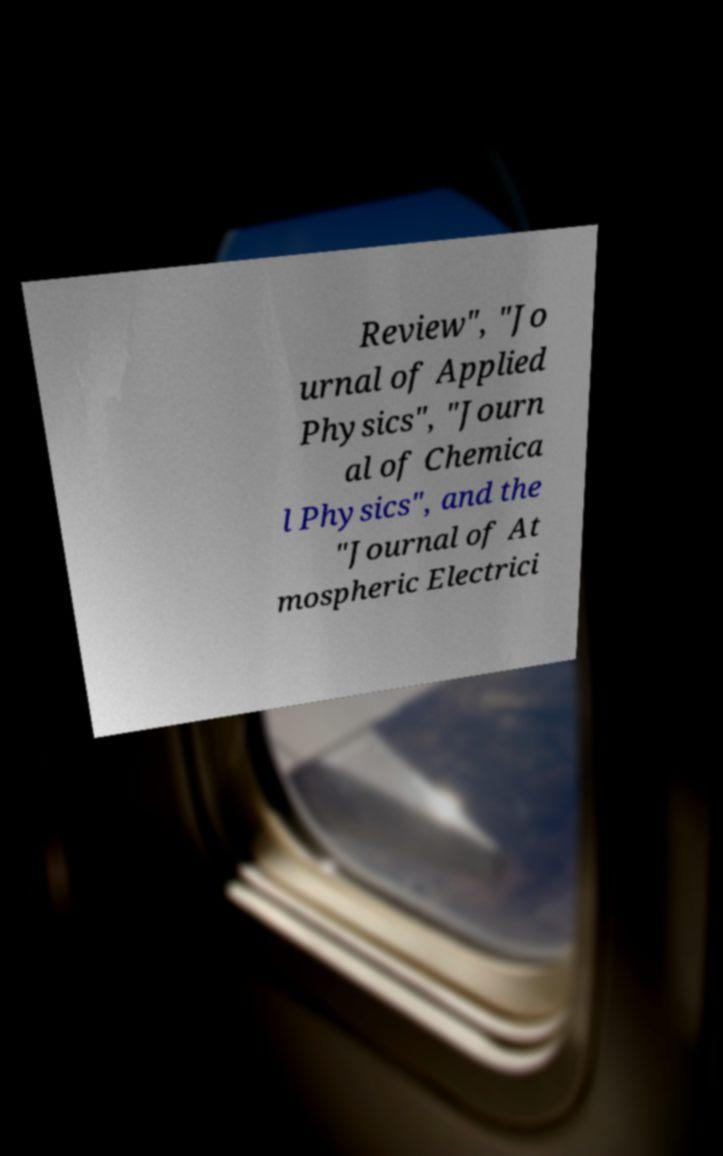Can you accurately transcribe the text from the provided image for me? Review", "Jo urnal of Applied Physics", "Journ al of Chemica l Physics", and the "Journal of At mospheric Electrici 